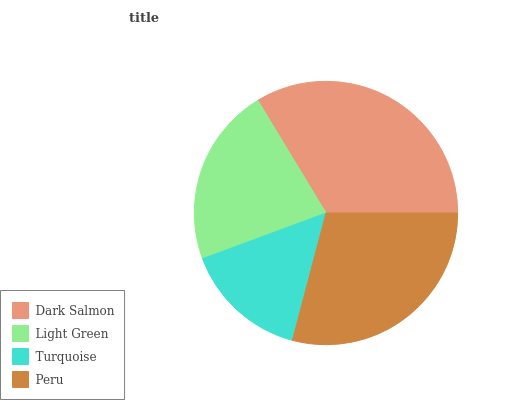Is Turquoise the minimum?
Answer yes or no. Yes. Is Dark Salmon the maximum?
Answer yes or no. Yes. Is Light Green the minimum?
Answer yes or no. No. Is Light Green the maximum?
Answer yes or no. No. Is Dark Salmon greater than Light Green?
Answer yes or no. Yes. Is Light Green less than Dark Salmon?
Answer yes or no. Yes. Is Light Green greater than Dark Salmon?
Answer yes or no. No. Is Dark Salmon less than Light Green?
Answer yes or no. No. Is Peru the high median?
Answer yes or no. Yes. Is Light Green the low median?
Answer yes or no. Yes. Is Dark Salmon the high median?
Answer yes or no. No. Is Turquoise the low median?
Answer yes or no. No. 